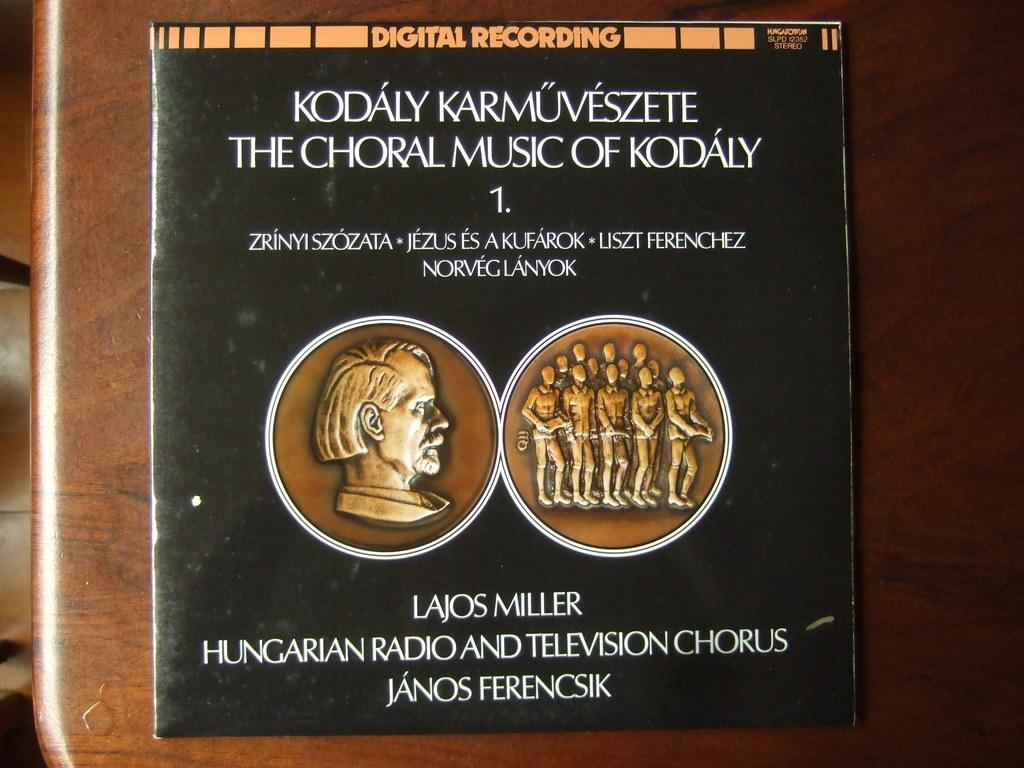Provide a one-sentence caption for the provided image. The cover for a digital recording about Hungarian choral music sits on wooden table. 